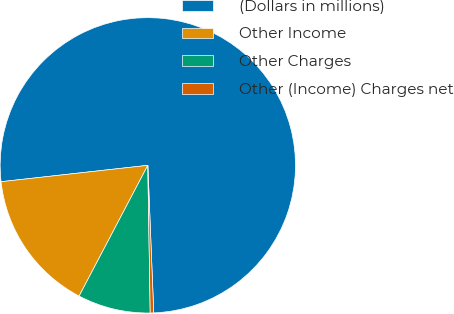Convert chart to OTSL. <chart><loc_0><loc_0><loc_500><loc_500><pie_chart><fcel>(Dollars in millions)<fcel>Other Income<fcel>Other Charges<fcel>Other (Income) Charges net<nl><fcel>76.13%<fcel>15.53%<fcel>7.96%<fcel>0.38%<nl></chart> 